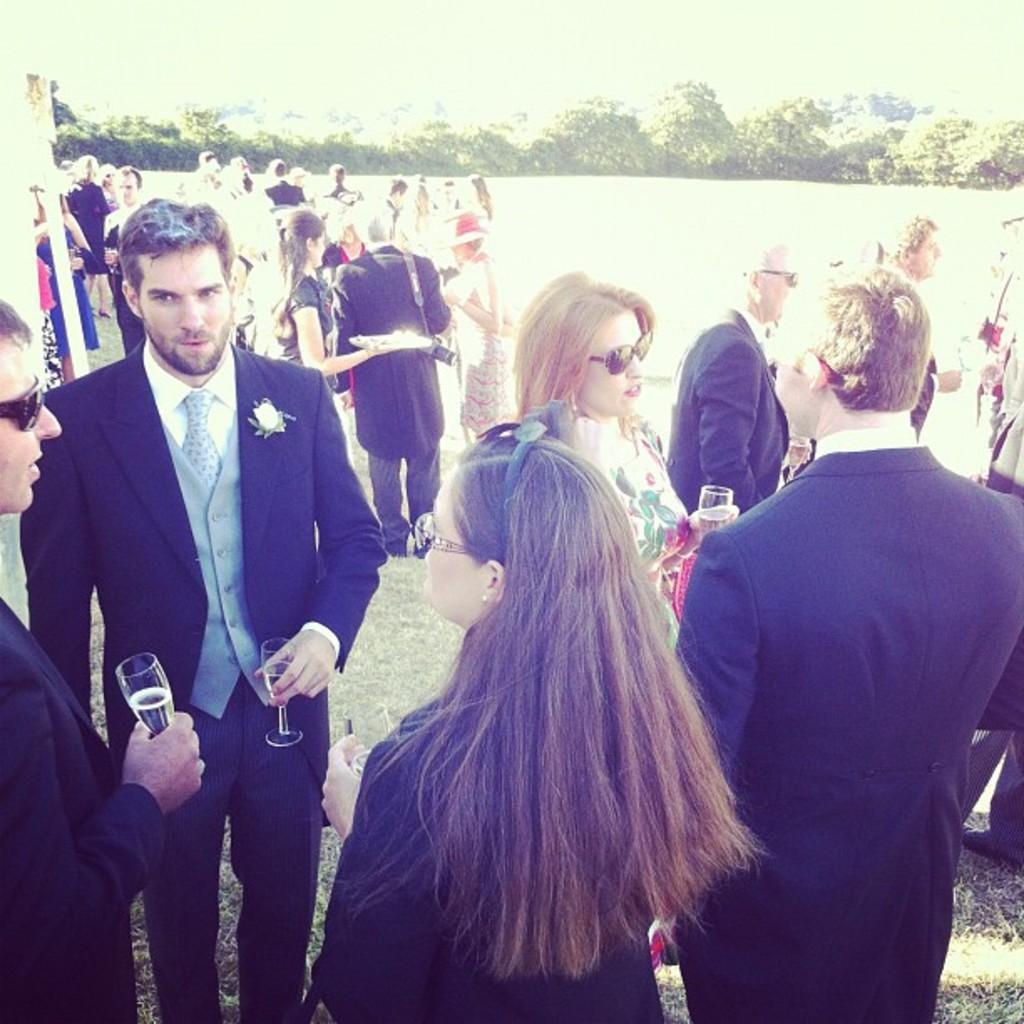How many people are in the image? There are people in the image, but the exact number is not specified. What are some of the people holding in the image? Some of the people are holding glasses, and one person is holding a plate. What else can be seen in the image besides people? There are plants in the image. Where is the maid standing in the image? There is no mention of a maid in the image, so we cannot answer this question. What color is the crayon being used by the person holding it in the image? There is no crayon present in the image. 